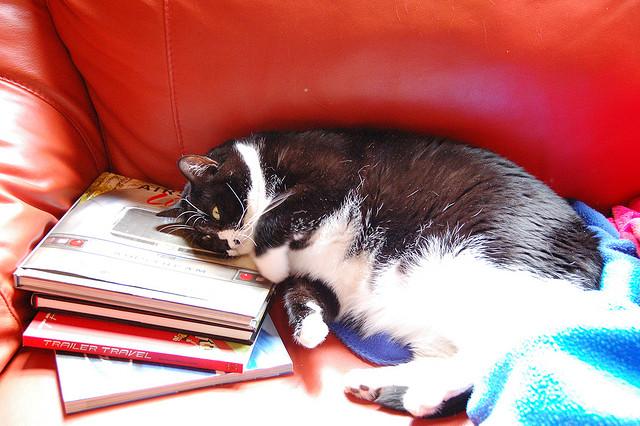What color is the cat?
Short answer required. Black and white. What color is the furniture?
Be succinct. Red. Is this cat tired?
Give a very brief answer. Yes. 